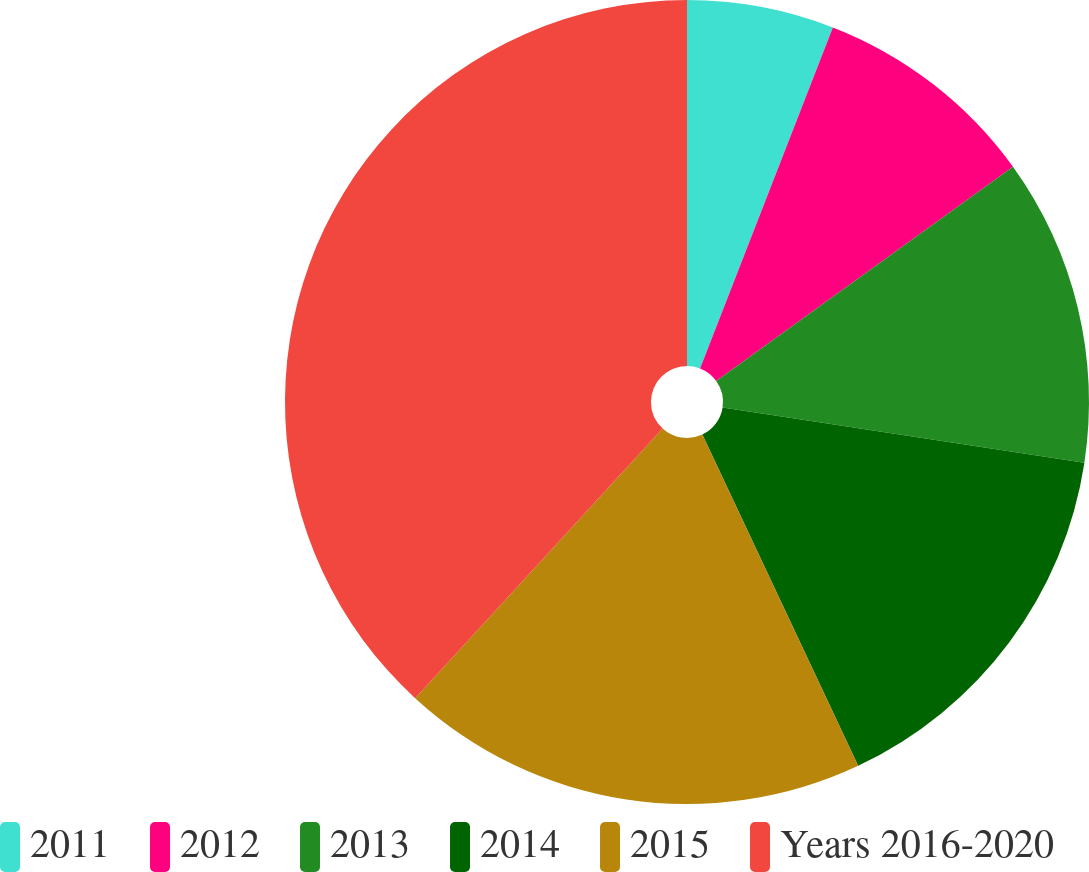Convert chart to OTSL. <chart><loc_0><loc_0><loc_500><loc_500><pie_chart><fcel>2011<fcel>2012<fcel>2013<fcel>2014<fcel>2015<fcel>Years 2016-2020<nl><fcel>5.91%<fcel>9.14%<fcel>12.36%<fcel>15.59%<fcel>18.82%<fcel>38.18%<nl></chart> 